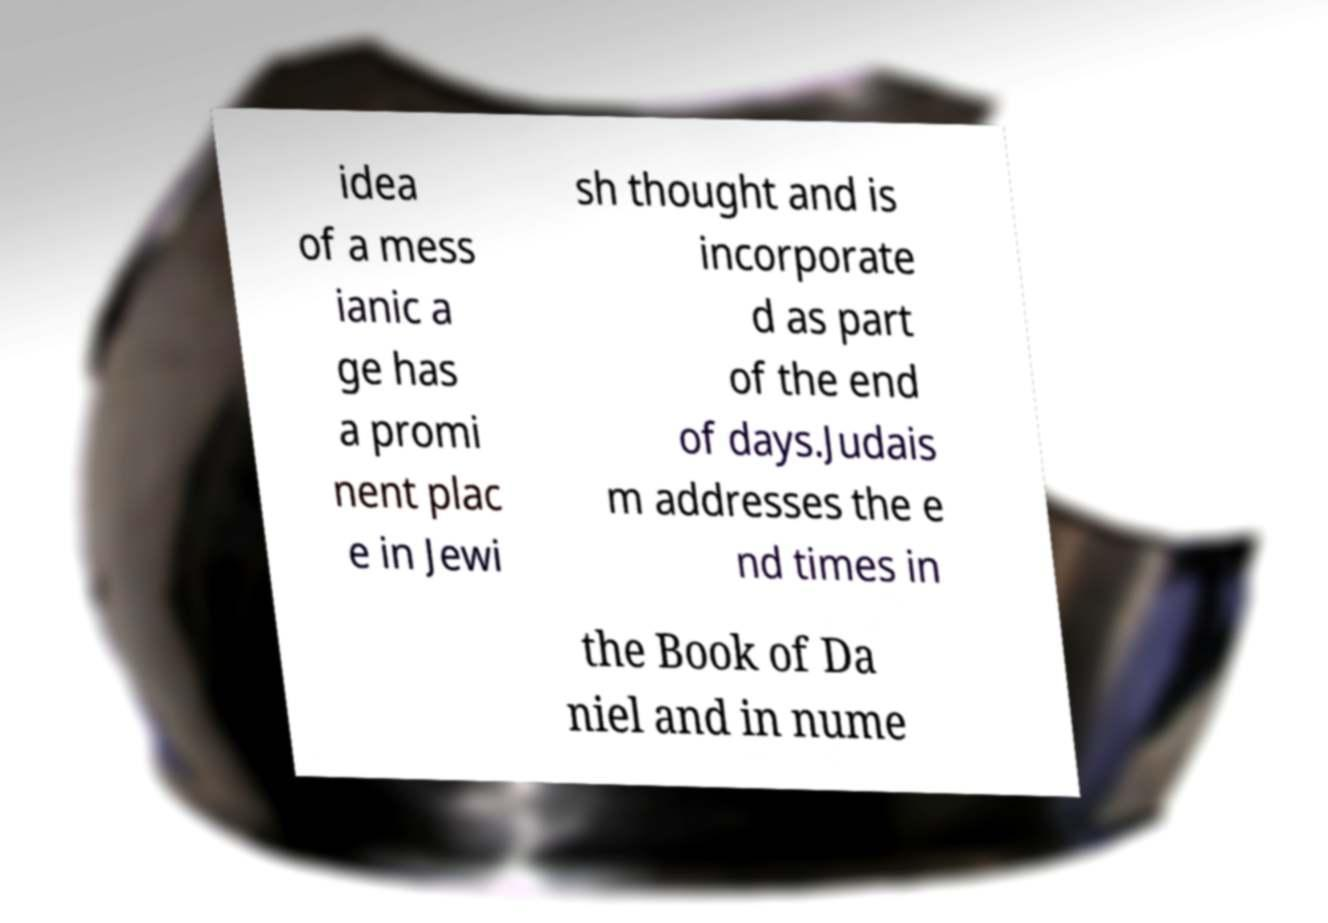What messages or text are displayed in this image? I need them in a readable, typed format. idea of a mess ianic a ge has a promi nent plac e in Jewi sh thought and is incorporate d as part of the end of days.Judais m addresses the e nd times in the Book of Da niel and in nume 